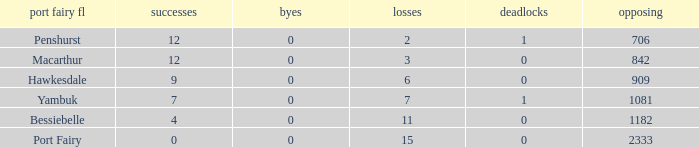How many draws when the Port Fairy FL is Hawkesdale and there are more than 9 wins? None. Give me the full table as a dictionary. {'header': ['port fairy fl', 'successes', 'byes', 'losses', 'deadlocks', 'opposing'], 'rows': [['Penshurst', '12', '0', '2', '1', '706'], ['Macarthur', '12', '0', '3', '0', '842'], ['Hawkesdale', '9', '0', '6', '0', '909'], ['Yambuk', '7', '0', '7', '1', '1081'], ['Bessiebelle', '4', '0', '11', '0', '1182'], ['Port Fairy', '0', '0', '15', '0', '2333']]} 